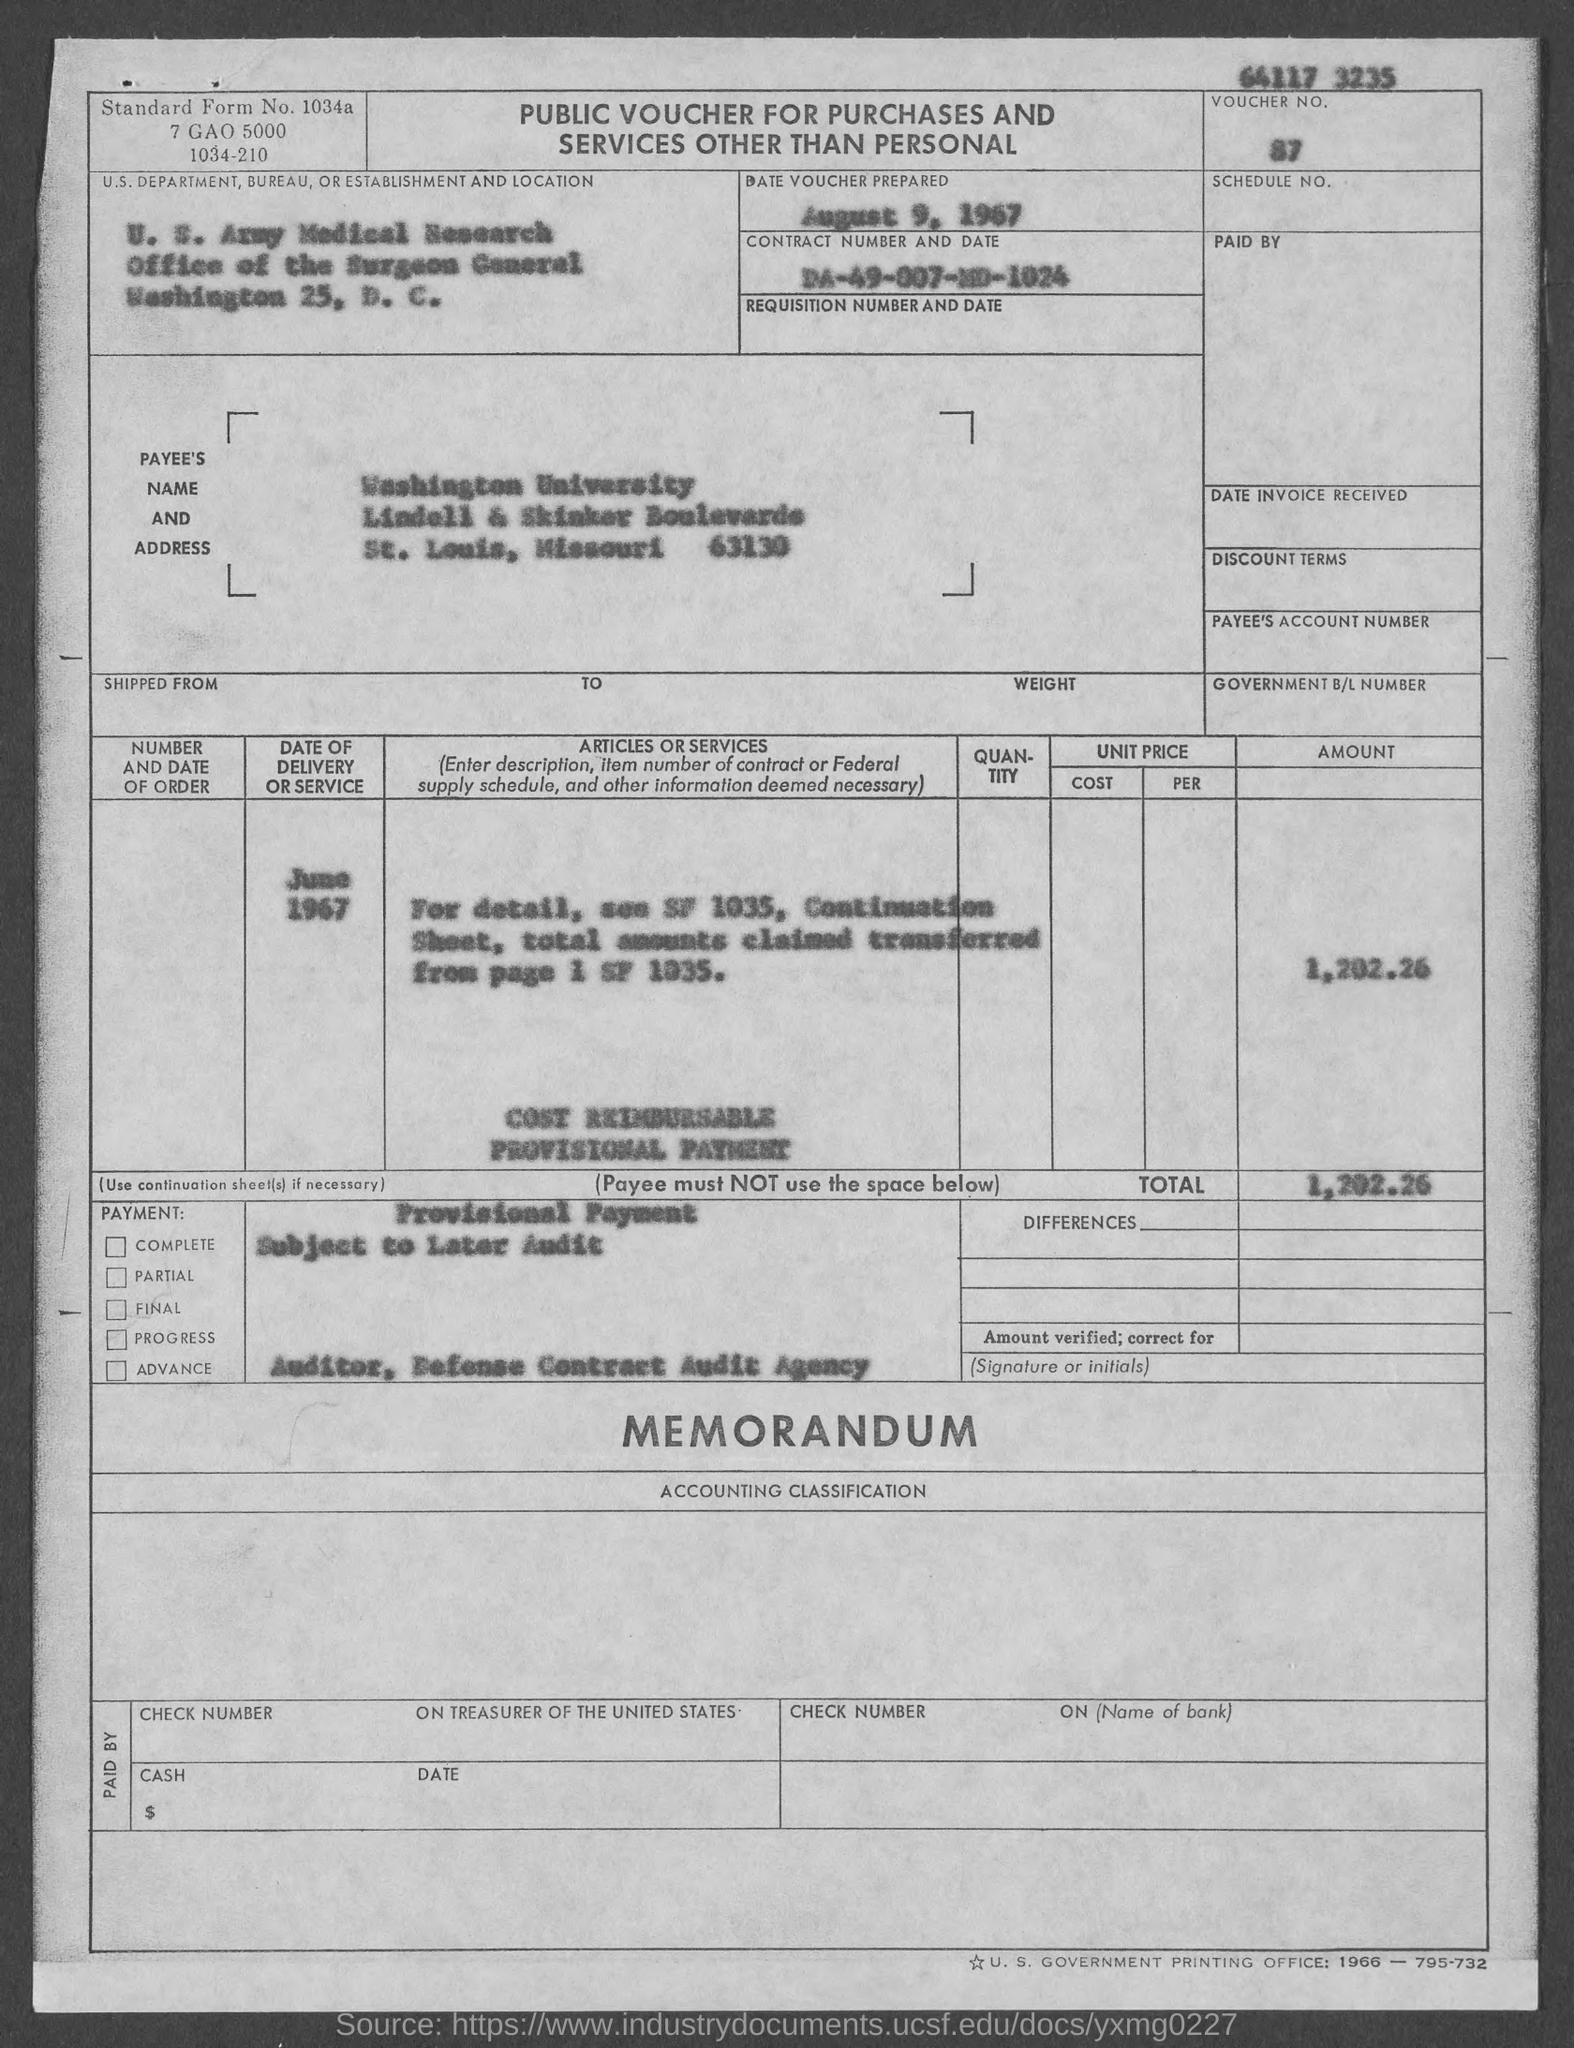What is the Voucher No.?
Ensure brevity in your answer.  87. What is the date of voucher prepared?
Your answer should be very brief. August 9, 1967. What is the Contract No.?
Give a very brief answer. DA-49-007-MD-1024. 